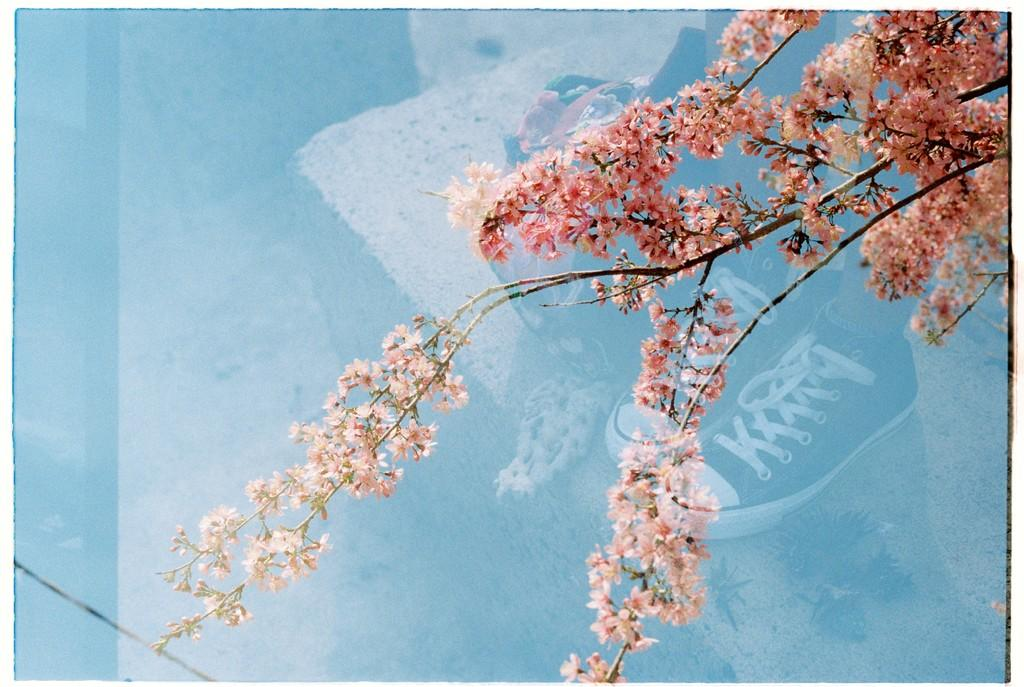What type of vegetation is on the tree in the image? There are flowers on the tree in the image. Can you describe the person in the image? There is a person in the image, and they are wearing shoes. What is the person's position in relation to the ground? The person is standing on the ground. What hobbies does the actor have, as seen in the image? There is no actor present in the image, and therefore no information about their hobbies can be determined. What type of vegetable is growing on the tree in the image? The tree in the image has flowers, not vegetables. 